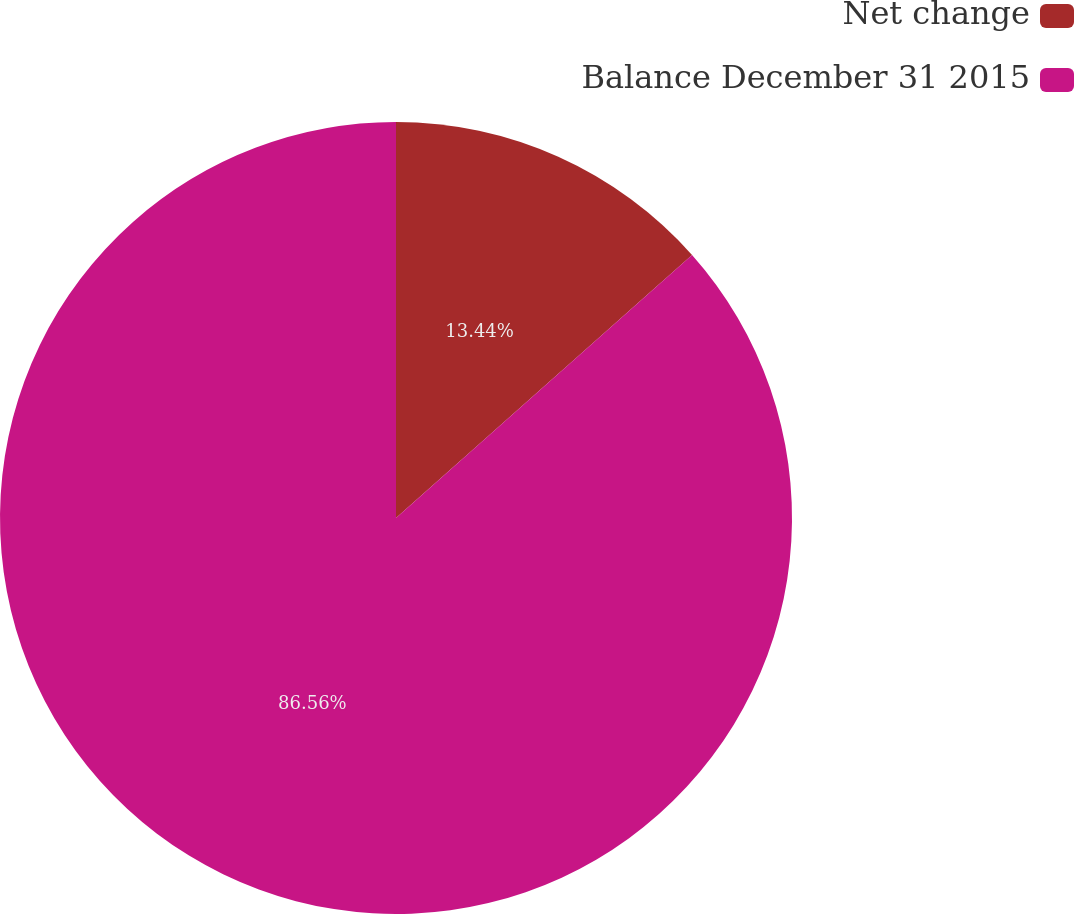Convert chart. <chart><loc_0><loc_0><loc_500><loc_500><pie_chart><fcel>Net change<fcel>Balance December 31 2015<nl><fcel>13.44%<fcel>86.56%<nl></chart> 